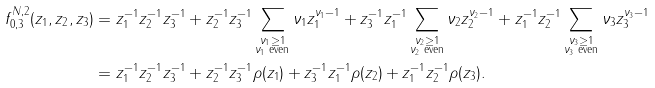Convert formula to latex. <formula><loc_0><loc_0><loc_500><loc_500>f _ { 0 , 3 } ^ { N , 2 } ( z _ { 1 } , z _ { 2 } , z _ { 3 } ) & = z _ { 1 } ^ { - 1 } z _ { 2 } ^ { - 1 } z _ { 3 } ^ { - 1 } + z _ { 2 } ^ { - 1 } z _ { 3 } ^ { - 1 } \sum _ { \substack { \nu _ { 1 } \geq 1 \\ \nu _ { 1 } \text { even} } } \nu _ { 1 } z _ { 1 } ^ { \nu _ { 1 } - 1 } + z _ { 3 } ^ { - 1 } z _ { 1 } ^ { - 1 } \sum _ { \substack { \nu _ { 2 } \geq 1 \\ \nu _ { 2 } \text { even} } } \nu _ { 2 } z _ { 2 } ^ { \nu _ { 2 } - 1 } + z _ { 1 } ^ { - 1 } z _ { 2 } ^ { - 1 } \sum _ { \substack { \nu _ { 3 } \geq 1 \\ \nu _ { 3 } \text { even} } } \nu _ { 3 } z _ { 3 } ^ { \nu _ { 3 } - 1 } \\ & = z _ { 1 } ^ { - 1 } z _ { 2 } ^ { - 1 } z _ { 3 } ^ { - 1 } + z _ { 2 } ^ { - 1 } z _ { 3 } ^ { - 1 } \rho ( z _ { 1 } ) + z _ { 3 } ^ { - 1 } z _ { 1 } ^ { - 1 } \rho ( z _ { 2 } ) + z _ { 1 } ^ { - 1 } z _ { 2 } ^ { - 1 } \rho ( z _ { 3 } ) .</formula> 